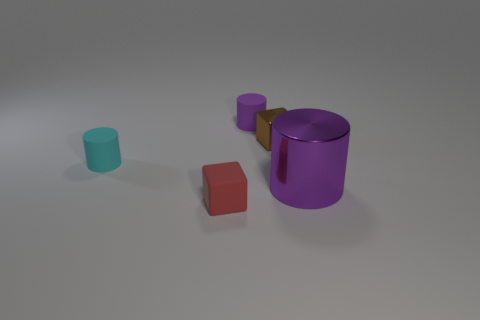Subtract all brown spheres. How many purple cylinders are left? 2 Subtract all big purple shiny cylinders. How many cylinders are left? 2 Add 4 tiny brown cubes. How many objects exist? 9 Subtract all brown cubes. How many cubes are left? 1 Subtract all cylinders. How many objects are left? 2 Subtract 0 brown cylinders. How many objects are left? 5 Subtract all brown cylinders. Subtract all yellow blocks. How many cylinders are left? 3 Subtract all cyan rubber objects. Subtract all big cyan matte blocks. How many objects are left? 4 Add 4 tiny red objects. How many tiny red objects are left? 5 Add 1 purple objects. How many purple objects exist? 3 